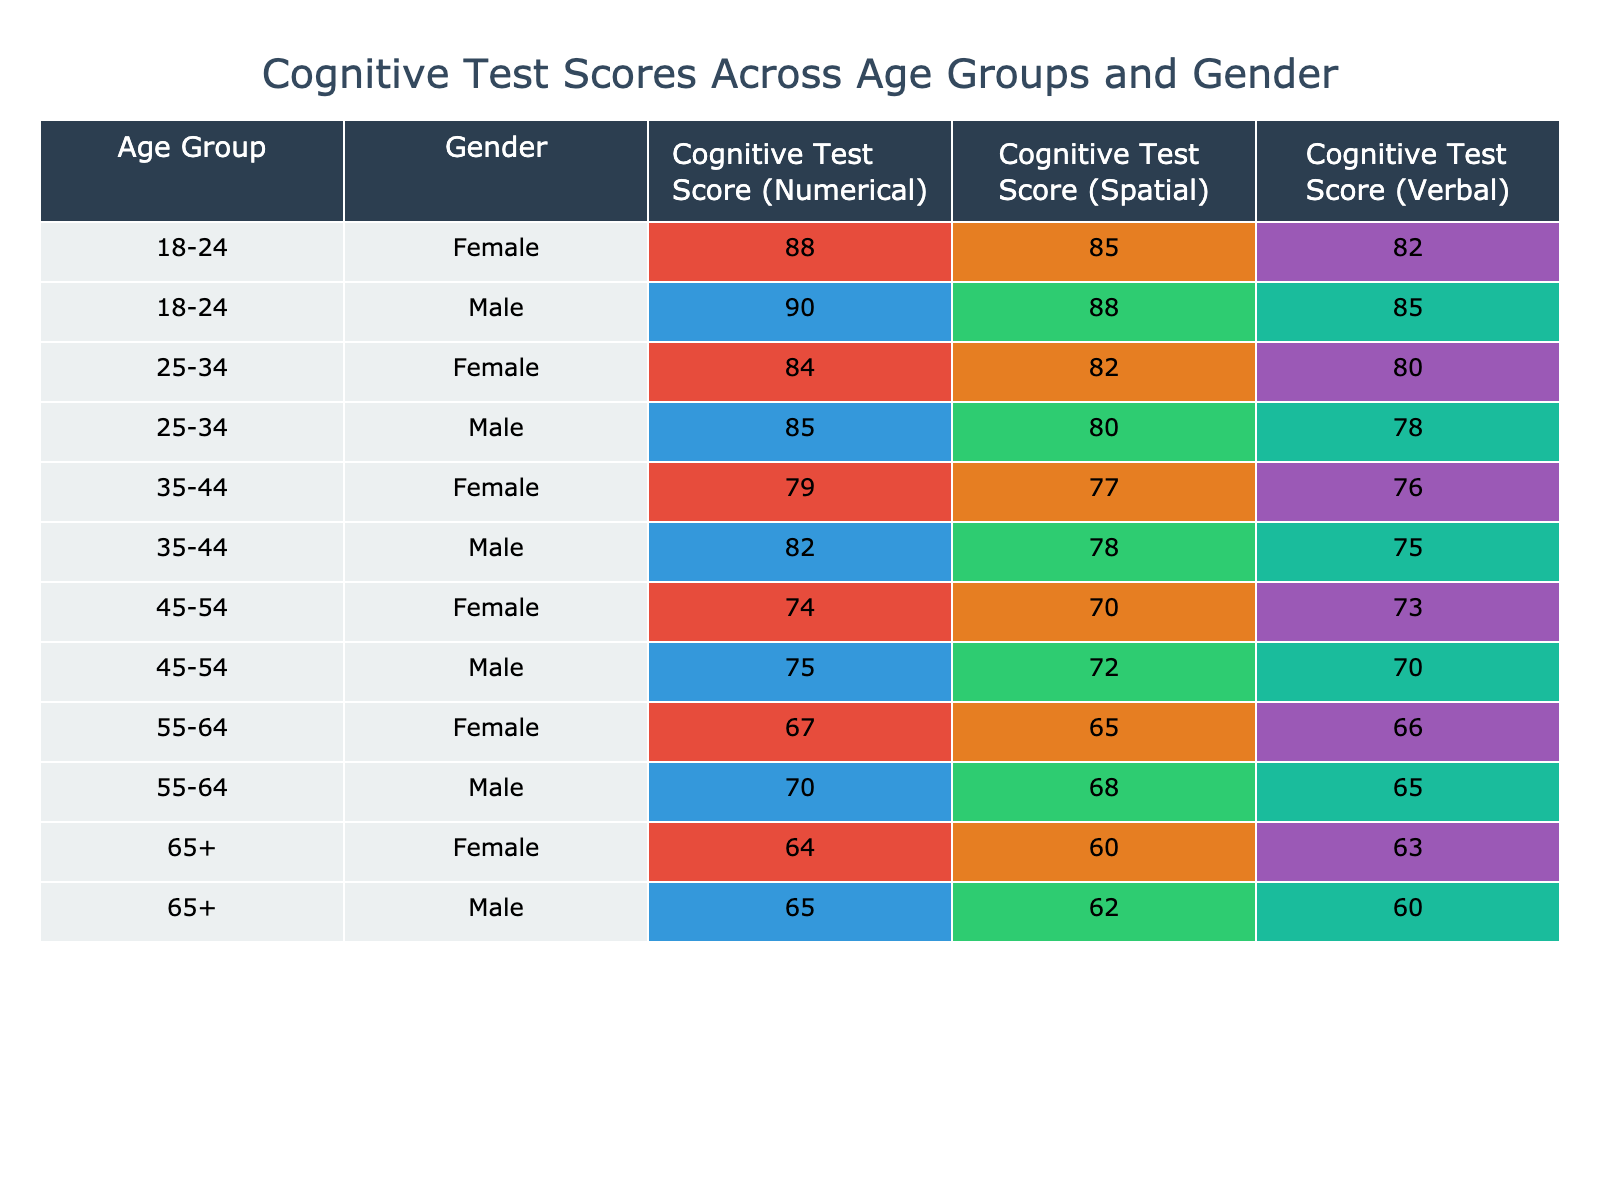What is the Cognitive Test Score (Verbal) for the age group 45-54 and gender Female? The score for females in the 45-54 age group is listed directly in the table as 73.
Answer: 73 What is the highest Cognitive Test Score (Numerical) among all Male participants? By inspecting the table, the highest Numerical score for Males is 90, which belongs to the 18-24 age group.
Answer: 90 What is the average Cognitive Test Score (Spatial) for Female participants across all age groups? For Females, the Spatial scores are 85, 82, 77, 70, 65, and 60. The sum is (85 + 82 + 77 + 70 + 65 + 60) = 439, and there are 6 scores, so the average is 439 / 6 = 73.17, which rounds to 73.
Answer: 73 Is the Cognitive Test Score (Verbal) for 35-44 age group Male participants higher than that for Female participants in the same age group? The Verbal scores for Males (75) and Females (76) in the 35-44 age group indicate that Females have a higher score than Males. Therefore, the statement is false.
Answer: No What is the difference in the average Cognitive Test Score (Numerical) between the 18-24 Male and Female participants? For Males in the 18-24 age group, the Numerical score is 90, and for Females, it is 88. The difference is 90 - 88, which equals 2.
Answer: 2 Which Gender has a better average performance in the Cognitive Test Score (Verbal) in the 25-34 age group? In the 25-34 age group, Males scored 78 while Females scored 80. Thus, Females have a better average score in this category.
Answer: Female What is the lowest Cognitive Test Score (Spatial) recorded among the participants? The table shows that the lowest Spatial score is 60, which belongs to Females in the 65+ age group.
Answer: 60 Is there a trend of decreasing Cognitive Test Scores as age increases for Male participants in the Numerical category? By comparing Numerical scores across age groups, we see scores of 90, 85, 82, 75, 70, and 65 for age groups from 18-24 to 65+. As age increases, the scores consistently decline, indicating a trend of decreasing scores.
Answer: Yes What is the combined total of Cognitive Test Scores (Verbal) for all Female participants aged 55-64? The Verbal scores for Females in the 55-64 age group is 66. Since it's the only score in that group, the total equals 66.
Answer: 66 